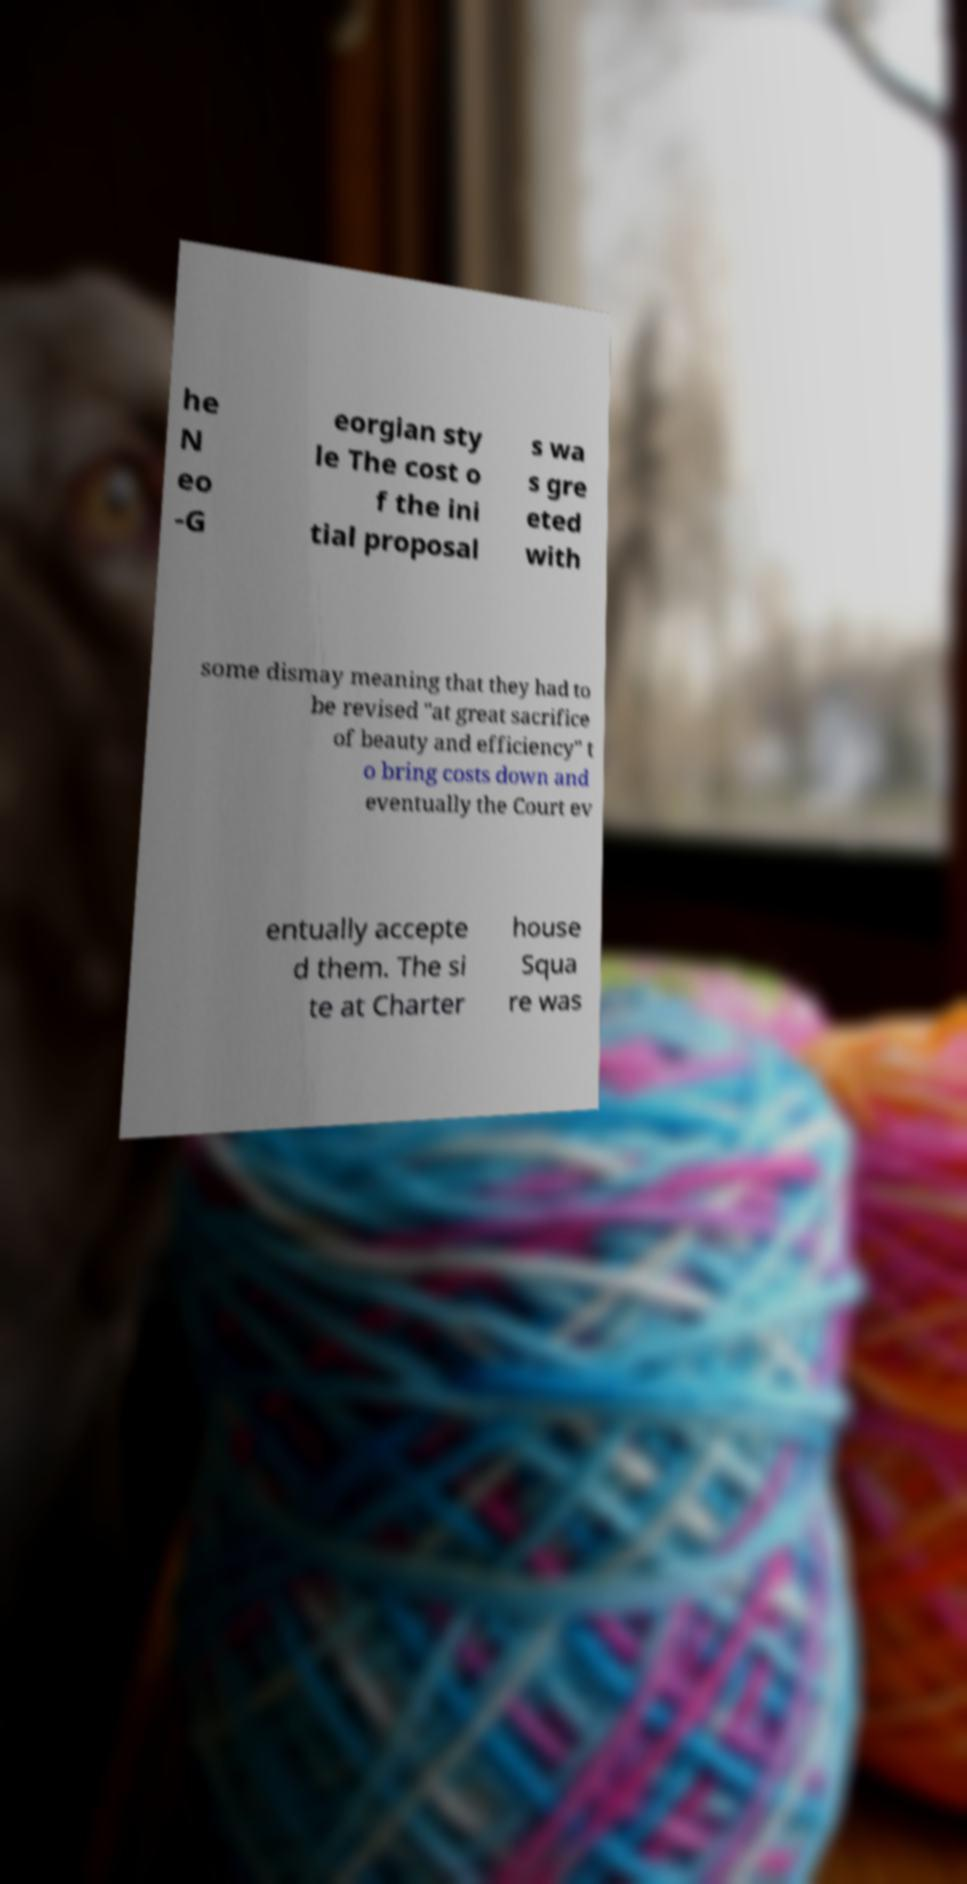Could you extract and type out the text from this image? he N eo -G eorgian sty le The cost o f the ini tial proposal s wa s gre eted with some dismay meaning that they had to be revised "at great sacrifice of beauty and efficiency" t o bring costs down and eventually the Court ev entually accepte d them. The si te at Charter house Squa re was 